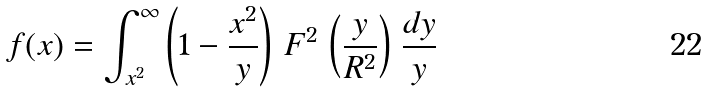Convert formula to latex. <formula><loc_0><loc_0><loc_500><loc_500>f ( x ) = \int _ { x ^ { 2 } } ^ { \infty } \left ( 1 - \frac { x ^ { 2 } } { y } \right ) \, F ^ { 2 } \, \left ( \frac { y } { R ^ { 2 } } \right ) \, \frac { d y } { y }</formula> 